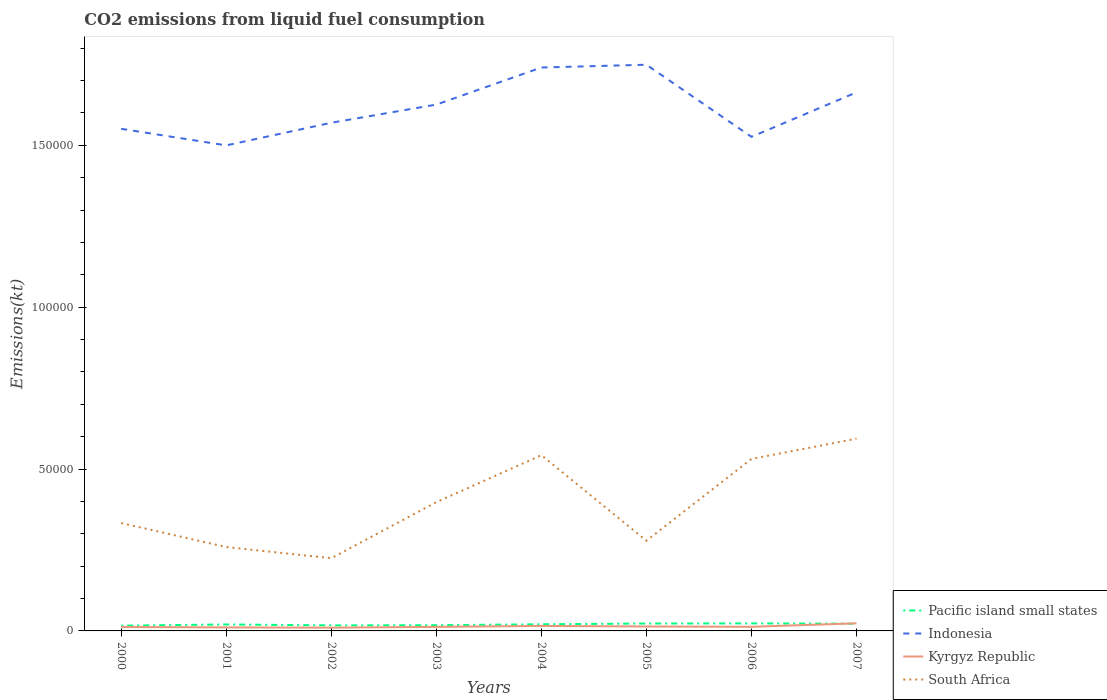Does the line corresponding to South Africa intersect with the line corresponding to Indonesia?
Keep it short and to the point. No. Across all years, what is the maximum amount of CO2 emitted in Indonesia?
Offer a terse response. 1.50e+05. In which year was the amount of CO2 emitted in Indonesia maximum?
Your response must be concise. 2001. What is the total amount of CO2 emitted in South Africa in the graph?
Give a very brief answer. -2.61e+04. What is the difference between the highest and the second highest amount of CO2 emitted in Pacific island small states?
Your answer should be very brief. 697.94. How many years are there in the graph?
Give a very brief answer. 8. Does the graph contain any zero values?
Give a very brief answer. No. How are the legend labels stacked?
Ensure brevity in your answer.  Vertical. What is the title of the graph?
Offer a very short reply. CO2 emissions from liquid fuel consumption. What is the label or title of the X-axis?
Keep it short and to the point. Years. What is the label or title of the Y-axis?
Keep it short and to the point. Emissions(kt). What is the Emissions(kt) of Pacific island small states in 2000?
Provide a succinct answer. 1628.52. What is the Emissions(kt) of Indonesia in 2000?
Offer a terse response. 1.55e+05. What is the Emissions(kt) of Kyrgyz Republic in 2000?
Your answer should be very brief. 1206.44. What is the Emissions(kt) in South Africa in 2000?
Your answer should be very brief. 3.33e+04. What is the Emissions(kt) of Pacific island small states in 2001?
Provide a succinct answer. 1997.8. What is the Emissions(kt) in Indonesia in 2001?
Make the answer very short. 1.50e+05. What is the Emissions(kt) of Kyrgyz Republic in 2001?
Your answer should be compact. 1085.43. What is the Emissions(kt) in South Africa in 2001?
Give a very brief answer. 2.59e+04. What is the Emissions(kt) in Pacific island small states in 2002?
Provide a short and direct response. 1709.77. What is the Emissions(kt) in Indonesia in 2002?
Keep it short and to the point. 1.57e+05. What is the Emissions(kt) of Kyrgyz Republic in 2002?
Your answer should be very brief. 1004.76. What is the Emissions(kt) of South Africa in 2002?
Your answer should be compact. 2.25e+04. What is the Emissions(kt) of Pacific island small states in 2003?
Offer a terse response. 1761.47. What is the Emissions(kt) in Indonesia in 2003?
Keep it short and to the point. 1.63e+05. What is the Emissions(kt) of Kyrgyz Republic in 2003?
Keep it short and to the point. 1246.78. What is the Emissions(kt) of South Africa in 2003?
Give a very brief answer. 3.98e+04. What is the Emissions(kt) of Pacific island small states in 2004?
Provide a succinct answer. 2060.58. What is the Emissions(kt) in Indonesia in 2004?
Provide a short and direct response. 1.74e+05. What is the Emissions(kt) of Kyrgyz Republic in 2004?
Provide a short and direct response. 1543.81. What is the Emissions(kt) of South Africa in 2004?
Offer a very short reply. 5.43e+04. What is the Emissions(kt) in Pacific island small states in 2005?
Give a very brief answer. 2285.84. What is the Emissions(kt) of Indonesia in 2005?
Your answer should be compact. 1.75e+05. What is the Emissions(kt) in Kyrgyz Republic in 2005?
Keep it short and to the point. 1371.46. What is the Emissions(kt) in South Africa in 2005?
Offer a terse response. 2.79e+04. What is the Emissions(kt) in Pacific island small states in 2006?
Give a very brief answer. 2326.46. What is the Emissions(kt) of Indonesia in 2006?
Keep it short and to the point. 1.53e+05. What is the Emissions(kt) of Kyrgyz Republic in 2006?
Keep it short and to the point. 1272.45. What is the Emissions(kt) of South Africa in 2006?
Offer a very short reply. 5.31e+04. What is the Emissions(kt) in Pacific island small states in 2007?
Your response must be concise. 2234.14. What is the Emissions(kt) of Indonesia in 2007?
Offer a terse response. 1.66e+05. What is the Emissions(kt) in Kyrgyz Republic in 2007?
Your answer should be compact. 2346.88. What is the Emissions(kt) in South Africa in 2007?
Make the answer very short. 5.94e+04. Across all years, what is the maximum Emissions(kt) of Pacific island small states?
Ensure brevity in your answer.  2326.46. Across all years, what is the maximum Emissions(kt) of Indonesia?
Keep it short and to the point. 1.75e+05. Across all years, what is the maximum Emissions(kt) of Kyrgyz Republic?
Keep it short and to the point. 2346.88. Across all years, what is the maximum Emissions(kt) of South Africa?
Your response must be concise. 5.94e+04. Across all years, what is the minimum Emissions(kt) in Pacific island small states?
Your answer should be very brief. 1628.52. Across all years, what is the minimum Emissions(kt) of Indonesia?
Your answer should be compact. 1.50e+05. Across all years, what is the minimum Emissions(kt) of Kyrgyz Republic?
Your answer should be compact. 1004.76. Across all years, what is the minimum Emissions(kt) of South Africa?
Provide a succinct answer. 2.25e+04. What is the total Emissions(kt) of Pacific island small states in the graph?
Keep it short and to the point. 1.60e+04. What is the total Emissions(kt) in Indonesia in the graph?
Ensure brevity in your answer.  1.29e+06. What is the total Emissions(kt) of Kyrgyz Republic in the graph?
Give a very brief answer. 1.11e+04. What is the total Emissions(kt) of South Africa in the graph?
Make the answer very short. 3.16e+05. What is the difference between the Emissions(kt) of Pacific island small states in 2000 and that in 2001?
Ensure brevity in your answer.  -369.28. What is the difference between the Emissions(kt) in Indonesia in 2000 and that in 2001?
Ensure brevity in your answer.  5122.8. What is the difference between the Emissions(kt) of Kyrgyz Republic in 2000 and that in 2001?
Give a very brief answer. 121.01. What is the difference between the Emissions(kt) of South Africa in 2000 and that in 2001?
Your response must be concise. 7422.01. What is the difference between the Emissions(kt) of Pacific island small states in 2000 and that in 2002?
Keep it short and to the point. -81.24. What is the difference between the Emissions(kt) of Indonesia in 2000 and that in 2002?
Provide a short and direct response. -1866.5. What is the difference between the Emissions(kt) in Kyrgyz Republic in 2000 and that in 2002?
Give a very brief answer. 201.69. What is the difference between the Emissions(kt) in South Africa in 2000 and that in 2002?
Provide a succinct answer. 1.09e+04. What is the difference between the Emissions(kt) in Pacific island small states in 2000 and that in 2003?
Offer a terse response. -132.94. What is the difference between the Emissions(kt) of Indonesia in 2000 and that in 2003?
Offer a very short reply. -7477.01. What is the difference between the Emissions(kt) in Kyrgyz Republic in 2000 and that in 2003?
Your answer should be very brief. -40.34. What is the difference between the Emissions(kt) in South Africa in 2000 and that in 2003?
Ensure brevity in your answer.  -6446.59. What is the difference between the Emissions(kt) of Pacific island small states in 2000 and that in 2004?
Offer a terse response. -432.06. What is the difference between the Emissions(kt) in Indonesia in 2000 and that in 2004?
Keep it short and to the point. -1.89e+04. What is the difference between the Emissions(kt) in Kyrgyz Republic in 2000 and that in 2004?
Ensure brevity in your answer.  -337.36. What is the difference between the Emissions(kt) in South Africa in 2000 and that in 2004?
Keep it short and to the point. -2.10e+04. What is the difference between the Emissions(kt) of Pacific island small states in 2000 and that in 2005?
Provide a succinct answer. -657.32. What is the difference between the Emissions(kt) in Indonesia in 2000 and that in 2005?
Your response must be concise. -1.98e+04. What is the difference between the Emissions(kt) of Kyrgyz Republic in 2000 and that in 2005?
Your response must be concise. -165.01. What is the difference between the Emissions(kt) in South Africa in 2000 and that in 2005?
Make the answer very short. 5471.16. What is the difference between the Emissions(kt) in Pacific island small states in 2000 and that in 2006?
Your answer should be very brief. -697.94. What is the difference between the Emissions(kt) in Indonesia in 2000 and that in 2006?
Provide a short and direct response. 2478.89. What is the difference between the Emissions(kt) of Kyrgyz Republic in 2000 and that in 2006?
Provide a short and direct response. -66.01. What is the difference between the Emissions(kt) in South Africa in 2000 and that in 2006?
Keep it short and to the point. -1.98e+04. What is the difference between the Emissions(kt) of Pacific island small states in 2000 and that in 2007?
Ensure brevity in your answer.  -605.62. What is the difference between the Emissions(kt) of Indonesia in 2000 and that in 2007?
Offer a terse response. -1.13e+04. What is the difference between the Emissions(kt) in Kyrgyz Republic in 2000 and that in 2007?
Offer a terse response. -1140.44. What is the difference between the Emissions(kt) in South Africa in 2000 and that in 2007?
Keep it short and to the point. -2.61e+04. What is the difference between the Emissions(kt) in Pacific island small states in 2001 and that in 2002?
Provide a short and direct response. 288.04. What is the difference between the Emissions(kt) in Indonesia in 2001 and that in 2002?
Offer a very short reply. -6989.3. What is the difference between the Emissions(kt) in Kyrgyz Republic in 2001 and that in 2002?
Offer a very short reply. 80.67. What is the difference between the Emissions(kt) of South Africa in 2001 and that in 2002?
Make the answer very short. 3439.65. What is the difference between the Emissions(kt) of Pacific island small states in 2001 and that in 2003?
Keep it short and to the point. 236.34. What is the difference between the Emissions(kt) of Indonesia in 2001 and that in 2003?
Provide a succinct answer. -1.26e+04. What is the difference between the Emissions(kt) in Kyrgyz Republic in 2001 and that in 2003?
Your response must be concise. -161.35. What is the difference between the Emissions(kt) in South Africa in 2001 and that in 2003?
Provide a succinct answer. -1.39e+04. What is the difference between the Emissions(kt) in Pacific island small states in 2001 and that in 2004?
Provide a succinct answer. -62.78. What is the difference between the Emissions(kt) in Indonesia in 2001 and that in 2004?
Your answer should be compact. -2.41e+04. What is the difference between the Emissions(kt) in Kyrgyz Republic in 2001 and that in 2004?
Your answer should be compact. -458.38. What is the difference between the Emissions(kt) in South Africa in 2001 and that in 2004?
Ensure brevity in your answer.  -2.84e+04. What is the difference between the Emissions(kt) in Pacific island small states in 2001 and that in 2005?
Keep it short and to the point. -288.04. What is the difference between the Emissions(kt) in Indonesia in 2001 and that in 2005?
Keep it short and to the point. -2.49e+04. What is the difference between the Emissions(kt) of Kyrgyz Republic in 2001 and that in 2005?
Your answer should be very brief. -286.03. What is the difference between the Emissions(kt) in South Africa in 2001 and that in 2005?
Your answer should be very brief. -1950.84. What is the difference between the Emissions(kt) in Pacific island small states in 2001 and that in 2006?
Your answer should be compact. -328.66. What is the difference between the Emissions(kt) in Indonesia in 2001 and that in 2006?
Keep it short and to the point. -2643.91. What is the difference between the Emissions(kt) in Kyrgyz Republic in 2001 and that in 2006?
Offer a very short reply. -187.02. What is the difference between the Emissions(kt) in South Africa in 2001 and that in 2006?
Your answer should be very brief. -2.72e+04. What is the difference between the Emissions(kt) in Pacific island small states in 2001 and that in 2007?
Your answer should be very brief. -236.34. What is the difference between the Emissions(kt) in Indonesia in 2001 and that in 2007?
Give a very brief answer. -1.64e+04. What is the difference between the Emissions(kt) of Kyrgyz Republic in 2001 and that in 2007?
Your response must be concise. -1261.45. What is the difference between the Emissions(kt) of South Africa in 2001 and that in 2007?
Keep it short and to the point. -3.35e+04. What is the difference between the Emissions(kt) in Pacific island small states in 2002 and that in 2003?
Keep it short and to the point. -51.7. What is the difference between the Emissions(kt) in Indonesia in 2002 and that in 2003?
Offer a very short reply. -5610.51. What is the difference between the Emissions(kt) in Kyrgyz Republic in 2002 and that in 2003?
Give a very brief answer. -242.02. What is the difference between the Emissions(kt) in South Africa in 2002 and that in 2003?
Offer a very short reply. -1.73e+04. What is the difference between the Emissions(kt) of Pacific island small states in 2002 and that in 2004?
Your answer should be compact. -350.82. What is the difference between the Emissions(kt) of Indonesia in 2002 and that in 2004?
Your answer should be compact. -1.71e+04. What is the difference between the Emissions(kt) of Kyrgyz Republic in 2002 and that in 2004?
Ensure brevity in your answer.  -539.05. What is the difference between the Emissions(kt) in South Africa in 2002 and that in 2004?
Give a very brief answer. -3.18e+04. What is the difference between the Emissions(kt) of Pacific island small states in 2002 and that in 2005?
Make the answer very short. -576.08. What is the difference between the Emissions(kt) in Indonesia in 2002 and that in 2005?
Offer a terse response. -1.79e+04. What is the difference between the Emissions(kt) of Kyrgyz Republic in 2002 and that in 2005?
Ensure brevity in your answer.  -366.7. What is the difference between the Emissions(kt) of South Africa in 2002 and that in 2005?
Offer a terse response. -5390.49. What is the difference between the Emissions(kt) of Pacific island small states in 2002 and that in 2006?
Keep it short and to the point. -616.7. What is the difference between the Emissions(kt) of Indonesia in 2002 and that in 2006?
Your response must be concise. 4345.4. What is the difference between the Emissions(kt) of Kyrgyz Republic in 2002 and that in 2006?
Make the answer very short. -267.69. What is the difference between the Emissions(kt) of South Africa in 2002 and that in 2006?
Ensure brevity in your answer.  -3.07e+04. What is the difference between the Emissions(kt) of Pacific island small states in 2002 and that in 2007?
Make the answer very short. -524.38. What is the difference between the Emissions(kt) of Indonesia in 2002 and that in 2007?
Provide a succinct answer. -9391.19. What is the difference between the Emissions(kt) of Kyrgyz Republic in 2002 and that in 2007?
Ensure brevity in your answer.  -1342.12. What is the difference between the Emissions(kt) in South Africa in 2002 and that in 2007?
Ensure brevity in your answer.  -3.69e+04. What is the difference between the Emissions(kt) of Pacific island small states in 2003 and that in 2004?
Provide a succinct answer. -299.12. What is the difference between the Emissions(kt) of Indonesia in 2003 and that in 2004?
Provide a short and direct response. -1.15e+04. What is the difference between the Emissions(kt) in Kyrgyz Republic in 2003 and that in 2004?
Your answer should be very brief. -297.03. What is the difference between the Emissions(kt) of South Africa in 2003 and that in 2004?
Offer a very short reply. -1.45e+04. What is the difference between the Emissions(kt) in Pacific island small states in 2003 and that in 2005?
Offer a terse response. -524.38. What is the difference between the Emissions(kt) in Indonesia in 2003 and that in 2005?
Your answer should be very brief. -1.23e+04. What is the difference between the Emissions(kt) of Kyrgyz Republic in 2003 and that in 2005?
Offer a terse response. -124.68. What is the difference between the Emissions(kt) in South Africa in 2003 and that in 2005?
Your answer should be very brief. 1.19e+04. What is the difference between the Emissions(kt) of Pacific island small states in 2003 and that in 2006?
Give a very brief answer. -565. What is the difference between the Emissions(kt) of Indonesia in 2003 and that in 2006?
Give a very brief answer. 9955.91. What is the difference between the Emissions(kt) of Kyrgyz Republic in 2003 and that in 2006?
Offer a very short reply. -25.67. What is the difference between the Emissions(kt) of South Africa in 2003 and that in 2006?
Offer a terse response. -1.34e+04. What is the difference between the Emissions(kt) in Pacific island small states in 2003 and that in 2007?
Your response must be concise. -472.68. What is the difference between the Emissions(kt) of Indonesia in 2003 and that in 2007?
Your response must be concise. -3780.68. What is the difference between the Emissions(kt) of Kyrgyz Republic in 2003 and that in 2007?
Provide a short and direct response. -1100.1. What is the difference between the Emissions(kt) in South Africa in 2003 and that in 2007?
Make the answer very short. -1.96e+04. What is the difference between the Emissions(kt) of Pacific island small states in 2004 and that in 2005?
Provide a short and direct response. -225.26. What is the difference between the Emissions(kt) in Indonesia in 2004 and that in 2005?
Your response must be concise. -861.75. What is the difference between the Emissions(kt) of Kyrgyz Republic in 2004 and that in 2005?
Offer a terse response. 172.35. What is the difference between the Emissions(kt) in South Africa in 2004 and that in 2005?
Ensure brevity in your answer.  2.64e+04. What is the difference between the Emissions(kt) in Pacific island small states in 2004 and that in 2006?
Provide a short and direct response. -265.88. What is the difference between the Emissions(kt) of Indonesia in 2004 and that in 2006?
Offer a terse response. 2.14e+04. What is the difference between the Emissions(kt) in Kyrgyz Republic in 2004 and that in 2006?
Make the answer very short. 271.36. What is the difference between the Emissions(kt) of South Africa in 2004 and that in 2006?
Your answer should be very brief. 1151.44. What is the difference between the Emissions(kt) of Pacific island small states in 2004 and that in 2007?
Ensure brevity in your answer.  -173.56. What is the difference between the Emissions(kt) in Indonesia in 2004 and that in 2007?
Ensure brevity in your answer.  7675.03. What is the difference between the Emissions(kt) in Kyrgyz Republic in 2004 and that in 2007?
Offer a terse response. -803.07. What is the difference between the Emissions(kt) in South Africa in 2004 and that in 2007?
Offer a very short reply. -5104.46. What is the difference between the Emissions(kt) in Pacific island small states in 2005 and that in 2006?
Provide a succinct answer. -40.62. What is the difference between the Emissions(kt) in Indonesia in 2005 and that in 2006?
Your response must be concise. 2.23e+04. What is the difference between the Emissions(kt) in Kyrgyz Republic in 2005 and that in 2006?
Offer a terse response. 99.01. What is the difference between the Emissions(kt) of South Africa in 2005 and that in 2006?
Ensure brevity in your answer.  -2.53e+04. What is the difference between the Emissions(kt) of Pacific island small states in 2005 and that in 2007?
Provide a succinct answer. 51.7. What is the difference between the Emissions(kt) in Indonesia in 2005 and that in 2007?
Your response must be concise. 8536.78. What is the difference between the Emissions(kt) of Kyrgyz Republic in 2005 and that in 2007?
Ensure brevity in your answer.  -975.42. What is the difference between the Emissions(kt) in South Africa in 2005 and that in 2007?
Give a very brief answer. -3.15e+04. What is the difference between the Emissions(kt) in Pacific island small states in 2006 and that in 2007?
Keep it short and to the point. 92.32. What is the difference between the Emissions(kt) in Indonesia in 2006 and that in 2007?
Your answer should be very brief. -1.37e+04. What is the difference between the Emissions(kt) in Kyrgyz Republic in 2006 and that in 2007?
Ensure brevity in your answer.  -1074.43. What is the difference between the Emissions(kt) of South Africa in 2006 and that in 2007?
Your answer should be compact. -6255.9. What is the difference between the Emissions(kt) of Pacific island small states in 2000 and the Emissions(kt) of Indonesia in 2001?
Your answer should be compact. -1.48e+05. What is the difference between the Emissions(kt) in Pacific island small states in 2000 and the Emissions(kt) in Kyrgyz Republic in 2001?
Provide a short and direct response. 543.09. What is the difference between the Emissions(kt) in Pacific island small states in 2000 and the Emissions(kt) in South Africa in 2001?
Keep it short and to the point. -2.43e+04. What is the difference between the Emissions(kt) in Indonesia in 2000 and the Emissions(kt) in Kyrgyz Republic in 2001?
Provide a short and direct response. 1.54e+05. What is the difference between the Emissions(kt) of Indonesia in 2000 and the Emissions(kt) of South Africa in 2001?
Give a very brief answer. 1.29e+05. What is the difference between the Emissions(kt) in Kyrgyz Republic in 2000 and the Emissions(kt) in South Africa in 2001?
Your response must be concise. -2.47e+04. What is the difference between the Emissions(kt) in Pacific island small states in 2000 and the Emissions(kt) in Indonesia in 2002?
Your answer should be very brief. -1.55e+05. What is the difference between the Emissions(kt) of Pacific island small states in 2000 and the Emissions(kt) of Kyrgyz Republic in 2002?
Offer a very short reply. 623.77. What is the difference between the Emissions(kt) of Pacific island small states in 2000 and the Emissions(kt) of South Africa in 2002?
Offer a very short reply. -2.08e+04. What is the difference between the Emissions(kt) of Indonesia in 2000 and the Emissions(kt) of Kyrgyz Republic in 2002?
Make the answer very short. 1.54e+05. What is the difference between the Emissions(kt) in Indonesia in 2000 and the Emissions(kt) in South Africa in 2002?
Give a very brief answer. 1.33e+05. What is the difference between the Emissions(kt) in Kyrgyz Republic in 2000 and the Emissions(kt) in South Africa in 2002?
Provide a short and direct response. -2.13e+04. What is the difference between the Emissions(kt) in Pacific island small states in 2000 and the Emissions(kt) in Indonesia in 2003?
Your response must be concise. -1.61e+05. What is the difference between the Emissions(kt) in Pacific island small states in 2000 and the Emissions(kt) in Kyrgyz Republic in 2003?
Your answer should be compact. 381.74. What is the difference between the Emissions(kt) of Pacific island small states in 2000 and the Emissions(kt) of South Africa in 2003?
Provide a succinct answer. -3.81e+04. What is the difference between the Emissions(kt) in Indonesia in 2000 and the Emissions(kt) in Kyrgyz Republic in 2003?
Your response must be concise. 1.54e+05. What is the difference between the Emissions(kt) of Indonesia in 2000 and the Emissions(kt) of South Africa in 2003?
Ensure brevity in your answer.  1.15e+05. What is the difference between the Emissions(kt) of Kyrgyz Republic in 2000 and the Emissions(kt) of South Africa in 2003?
Offer a very short reply. -3.86e+04. What is the difference between the Emissions(kt) of Pacific island small states in 2000 and the Emissions(kt) of Indonesia in 2004?
Provide a short and direct response. -1.72e+05. What is the difference between the Emissions(kt) of Pacific island small states in 2000 and the Emissions(kt) of Kyrgyz Republic in 2004?
Provide a short and direct response. 84.72. What is the difference between the Emissions(kt) of Pacific island small states in 2000 and the Emissions(kt) of South Africa in 2004?
Provide a short and direct response. -5.27e+04. What is the difference between the Emissions(kt) in Indonesia in 2000 and the Emissions(kt) in Kyrgyz Republic in 2004?
Your response must be concise. 1.54e+05. What is the difference between the Emissions(kt) of Indonesia in 2000 and the Emissions(kt) of South Africa in 2004?
Provide a short and direct response. 1.01e+05. What is the difference between the Emissions(kt) of Kyrgyz Republic in 2000 and the Emissions(kt) of South Africa in 2004?
Ensure brevity in your answer.  -5.31e+04. What is the difference between the Emissions(kt) in Pacific island small states in 2000 and the Emissions(kt) in Indonesia in 2005?
Offer a very short reply. -1.73e+05. What is the difference between the Emissions(kt) of Pacific island small states in 2000 and the Emissions(kt) of Kyrgyz Republic in 2005?
Ensure brevity in your answer.  257.07. What is the difference between the Emissions(kt) of Pacific island small states in 2000 and the Emissions(kt) of South Africa in 2005?
Offer a terse response. -2.62e+04. What is the difference between the Emissions(kt) of Indonesia in 2000 and the Emissions(kt) of Kyrgyz Republic in 2005?
Your answer should be compact. 1.54e+05. What is the difference between the Emissions(kt) in Indonesia in 2000 and the Emissions(kt) in South Africa in 2005?
Offer a very short reply. 1.27e+05. What is the difference between the Emissions(kt) in Kyrgyz Republic in 2000 and the Emissions(kt) in South Africa in 2005?
Keep it short and to the point. -2.67e+04. What is the difference between the Emissions(kt) in Pacific island small states in 2000 and the Emissions(kt) in Indonesia in 2006?
Keep it short and to the point. -1.51e+05. What is the difference between the Emissions(kt) in Pacific island small states in 2000 and the Emissions(kt) in Kyrgyz Republic in 2006?
Your answer should be very brief. 356.08. What is the difference between the Emissions(kt) in Pacific island small states in 2000 and the Emissions(kt) in South Africa in 2006?
Your answer should be very brief. -5.15e+04. What is the difference between the Emissions(kt) in Indonesia in 2000 and the Emissions(kt) in Kyrgyz Republic in 2006?
Keep it short and to the point. 1.54e+05. What is the difference between the Emissions(kt) of Indonesia in 2000 and the Emissions(kt) of South Africa in 2006?
Provide a succinct answer. 1.02e+05. What is the difference between the Emissions(kt) of Kyrgyz Republic in 2000 and the Emissions(kt) of South Africa in 2006?
Offer a very short reply. -5.19e+04. What is the difference between the Emissions(kt) in Pacific island small states in 2000 and the Emissions(kt) in Indonesia in 2007?
Offer a very short reply. -1.65e+05. What is the difference between the Emissions(kt) of Pacific island small states in 2000 and the Emissions(kt) of Kyrgyz Republic in 2007?
Provide a short and direct response. -718.36. What is the difference between the Emissions(kt) in Pacific island small states in 2000 and the Emissions(kt) in South Africa in 2007?
Your response must be concise. -5.78e+04. What is the difference between the Emissions(kt) in Indonesia in 2000 and the Emissions(kt) in Kyrgyz Republic in 2007?
Make the answer very short. 1.53e+05. What is the difference between the Emissions(kt) of Indonesia in 2000 and the Emissions(kt) of South Africa in 2007?
Provide a succinct answer. 9.57e+04. What is the difference between the Emissions(kt) in Kyrgyz Republic in 2000 and the Emissions(kt) in South Africa in 2007?
Provide a succinct answer. -5.82e+04. What is the difference between the Emissions(kt) in Pacific island small states in 2001 and the Emissions(kt) in Indonesia in 2002?
Offer a terse response. -1.55e+05. What is the difference between the Emissions(kt) in Pacific island small states in 2001 and the Emissions(kt) in Kyrgyz Republic in 2002?
Provide a succinct answer. 993.05. What is the difference between the Emissions(kt) of Pacific island small states in 2001 and the Emissions(kt) of South Africa in 2002?
Provide a short and direct response. -2.05e+04. What is the difference between the Emissions(kt) in Indonesia in 2001 and the Emissions(kt) in Kyrgyz Republic in 2002?
Offer a very short reply. 1.49e+05. What is the difference between the Emissions(kt) of Indonesia in 2001 and the Emissions(kt) of South Africa in 2002?
Offer a terse response. 1.28e+05. What is the difference between the Emissions(kt) of Kyrgyz Republic in 2001 and the Emissions(kt) of South Africa in 2002?
Offer a very short reply. -2.14e+04. What is the difference between the Emissions(kt) of Pacific island small states in 2001 and the Emissions(kt) of Indonesia in 2003?
Your answer should be very brief. -1.61e+05. What is the difference between the Emissions(kt) in Pacific island small states in 2001 and the Emissions(kt) in Kyrgyz Republic in 2003?
Provide a short and direct response. 751.02. What is the difference between the Emissions(kt) of Pacific island small states in 2001 and the Emissions(kt) of South Africa in 2003?
Your answer should be very brief. -3.78e+04. What is the difference between the Emissions(kt) of Indonesia in 2001 and the Emissions(kt) of Kyrgyz Republic in 2003?
Keep it short and to the point. 1.49e+05. What is the difference between the Emissions(kt) of Indonesia in 2001 and the Emissions(kt) of South Africa in 2003?
Ensure brevity in your answer.  1.10e+05. What is the difference between the Emissions(kt) of Kyrgyz Republic in 2001 and the Emissions(kt) of South Africa in 2003?
Make the answer very short. -3.87e+04. What is the difference between the Emissions(kt) in Pacific island small states in 2001 and the Emissions(kt) in Indonesia in 2004?
Offer a very short reply. -1.72e+05. What is the difference between the Emissions(kt) of Pacific island small states in 2001 and the Emissions(kt) of Kyrgyz Republic in 2004?
Provide a succinct answer. 454. What is the difference between the Emissions(kt) of Pacific island small states in 2001 and the Emissions(kt) of South Africa in 2004?
Offer a very short reply. -5.23e+04. What is the difference between the Emissions(kt) in Indonesia in 2001 and the Emissions(kt) in Kyrgyz Republic in 2004?
Your response must be concise. 1.48e+05. What is the difference between the Emissions(kt) in Indonesia in 2001 and the Emissions(kt) in South Africa in 2004?
Offer a very short reply. 9.57e+04. What is the difference between the Emissions(kt) of Kyrgyz Republic in 2001 and the Emissions(kt) of South Africa in 2004?
Your response must be concise. -5.32e+04. What is the difference between the Emissions(kt) of Pacific island small states in 2001 and the Emissions(kt) of Indonesia in 2005?
Your response must be concise. -1.73e+05. What is the difference between the Emissions(kt) of Pacific island small states in 2001 and the Emissions(kt) of Kyrgyz Republic in 2005?
Provide a short and direct response. 626.35. What is the difference between the Emissions(kt) in Pacific island small states in 2001 and the Emissions(kt) in South Africa in 2005?
Offer a very short reply. -2.59e+04. What is the difference between the Emissions(kt) of Indonesia in 2001 and the Emissions(kt) of Kyrgyz Republic in 2005?
Keep it short and to the point. 1.49e+05. What is the difference between the Emissions(kt) in Indonesia in 2001 and the Emissions(kt) in South Africa in 2005?
Offer a very short reply. 1.22e+05. What is the difference between the Emissions(kt) in Kyrgyz Republic in 2001 and the Emissions(kt) in South Africa in 2005?
Your answer should be compact. -2.68e+04. What is the difference between the Emissions(kt) in Pacific island small states in 2001 and the Emissions(kt) in Indonesia in 2006?
Provide a short and direct response. -1.51e+05. What is the difference between the Emissions(kt) of Pacific island small states in 2001 and the Emissions(kt) of Kyrgyz Republic in 2006?
Provide a succinct answer. 725.36. What is the difference between the Emissions(kt) in Pacific island small states in 2001 and the Emissions(kt) in South Africa in 2006?
Provide a succinct answer. -5.11e+04. What is the difference between the Emissions(kt) in Indonesia in 2001 and the Emissions(kt) in Kyrgyz Republic in 2006?
Provide a succinct answer. 1.49e+05. What is the difference between the Emissions(kt) in Indonesia in 2001 and the Emissions(kt) in South Africa in 2006?
Provide a succinct answer. 9.68e+04. What is the difference between the Emissions(kt) of Kyrgyz Republic in 2001 and the Emissions(kt) of South Africa in 2006?
Offer a terse response. -5.20e+04. What is the difference between the Emissions(kt) in Pacific island small states in 2001 and the Emissions(kt) in Indonesia in 2007?
Your answer should be very brief. -1.64e+05. What is the difference between the Emissions(kt) of Pacific island small states in 2001 and the Emissions(kt) of Kyrgyz Republic in 2007?
Provide a succinct answer. -349.08. What is the difference between the Emissions(kt) of Pacific island small states in 2001 and the Emissions(kt) of South Africa in 2007?
Your answer should be compact. -5.74e+04. What is the difference between the Emissions(kt) of Indonesia in 2001 and the Emissions(kt) of Kyrgyz Republic in 2007?
Offer a very short reply. 1.48e+05. What is the difference between the Emissions(kt) in Indonesia in 2001 and the Emissions(kt) in South Africa in 2007?
Your response must be concise. 9.06e+04. What is the difference between the Emissions(kt) of Kyrgyz Republic in 2001 and the Emissions(kt) of South Africa in 2007?
Your response must be concise. -5.83e+04. What is the difference between the Emissions(kt) in Pacific island small states in 2002 and the Emissions(kt) in Indonesia in 2003?
Provide a short and direct response. -1.61e+05. What is the difference between the Emissions(kt) in Pacific island small states in 2002 and the Emissions(kt) in Kyrgyz Republic in 2003?
Offer a terse response. 462.99. What is the difference between the Emissions(kt) of Pacific island small states in 2002 and the Emissions(kt) of South Africa in 2003?
Ensure brevity in your answer.  -3.81e+04. What is the difference between the Emissions(kt) in Indonesia in 2002 and the Emissions(kt) in Kyrgyz Republic in 2003?
Your answer should be very brief. 1.56e+05. What is the difference between the Emissions(kt) of Indonesia in 2002 and the Emissions(kt) of South Africa in 2003?
Make the answer very short. 1.17e+05. What is the difference between the Emissions(kt) in Kyrgyz Republic in 2002 and the Emissions(kt) in South Africa in 2003?
Make the answer very short. -3.88e+04. What is the difference between the Emissions(kt) in Pacific island small states in 2002 and the Emissions(kt) in Indonesia in 2004?
Give a very brief answer. -1.72e+05. What is the difference between the Emissions(kt) in Pacific island small states in 2002 and the Emissions(kt) in Kyrgyz Republic in 2004?
Give a very brief answer. 165.96. What is the difference between the Emissions(kt) of Pacific island small states in 2002 and the Emissions(kt) of South Africa in 2004?
Give a very brief answer. -5.26e+04. What is the difference between the Emissions(kt) of Indonesia in 2002 and the Emissions(kt) of Kyrgyz Republic in 2004?
Keep it short and to the point. 1.55e+05. What is the difference between the Emissions(kt) of Indonesia in 2002 and the Emissions(kt) of South Africa in 2004?
Your response must be concise. 1.03e+05. What is the difference between the Emissions(kt) of Kyrgyz Republic in 2002 and the Emissions(kt) of South Africa in 2004?
Ensure brevity in your answer.  -5.33e+04. What is the difference between the Emissions(kt) of Pacific island small states in 2002 and the Emissions(kt) of Indonesia in 2005?
Provide a short and direct response. -1.73e+05. What is the difference between the Emissions(kt) in Pacific island small states in 2002 and the Emissions(kt) in Kyrgyz Republic in 2005?
Offer a terse response. 338.31. What is the difference between the Emissions(kt) of Pacific island small states in 2002 and the Emissions(kt) of South Africa in 2005?
Provide a succinct answer. -2.61e+04. What is the difference between the Emissions(kt) of Indonesia in 2002 and the Emissions(kt) of Kyrgyz Republic in 2005?
Provide a short and direct response. 1.56e+05. What is the difference between the Emissions(kt) of Indonesia in 2002 and the Emissions(kt) of South Africa in 2005?
Ensure brevity in your answer.  1.29e+05. What is the difference between the Emissions(kt) of Kyrgyz Republic in 2002 and the Emissions(kt) of South Africa in 2005?
Your answer should be very brief. -2.69e+04. What is the difference between the Emissions(kt) of Pacific island small states in 2002 and the Emissions(kt) of Indonesia in 2006?
Your answer should be very brief. -1.51e+05. What is the difference between the Emissions(kt) of Pacific island small states in 2002 and the Emissions(kt) of Kyrgyz Republic in 2006?
Your answer should be very brief. 437.32. What is the difference between the Emissions(kt) of Pacific island small states in 2002 and the Emissions(kt) of South Africa in 2006?
Offer a very short reply. -5.14e+04. What is the difference between the Emissions(kt) in Indonesia in 2002 and the Emissions(kt) in Kyrgyz Republic in 2006?
Provide a succinct answer. 1.56e+05. What is the difference between the Emissions(kt) of Indonesia in 2002 and the Emissions(kt) of South Africa in 2006?
Give a very brief answer. 1.04e+05. What is the difference between the Emissions(kt) in Kyrgyz Republic in 2002 and the Emissions(kt) in South Africa in 2006?
Your response must be concise. -5.21e+04. What is the difference between the Emissions(kt) in Pacific island small states in 2002 and the Emissions(kt) in Indonesia in 2007?
Provide a succinct answer. -1.65e+05. What is the difference between the Emissions(kt) of Pacific island small states in 2002 and the Emissions(kt) of Kyrgyz Republic in 2007?
Your response must be concise. -637.11. What is the difference between the Emissions(kt) in Pacific island small states in 2002 and the Emissions(kt) in South Africa in 2007?
Make the answer very short. -5.77e+04. What is the difference between the Emissions(kt) of Indonesia in 2002 and the Emissions(kt) of Kyrgyz Republic in 2007?
Offer a very short reply. 1.55e+05. What is the difference between the Emissions(kt) of Indonesia in 2002 and the Emissions(kt) of South Africa in 2007?
Your answer should be compact. 9.76e+04. What is the difference between the Emissions(kt) in Kyrgyz Republic in 2002 and the Emissions(kt) in South Africa in 2007?
Your response must be concise. -5.84e+04. What is the difference between the Emissions(kt) in Pacific island small states in 2003 and the Emissions(kt) in Indonesia in 2004?
Offer a very short reply. -1.72e+05. What is the difference between the Emissions(kt) of Pacific island small states in 2003 and the Emissions(kt) of Kyrgyz Republic in 2004?
Give a very brief answer. 217.66. What is the difference between the Emissions(kt) in Pacific island small states in 2003 and the Emissions(kt) in South Africa in 2004?
Give a very brief answer. -5.25e+04. What is the difference between the Emissions(kt) in Indonesia in 2003 and the Emissions(kt) in Kyrgyz Republic in 2004?
Your answer should be compact. 1.61e+05. What is the difference between the Emissions(kt) in Indonesia in 2003 and the Emissions(kt) in South Africa in 2004?
Provide a short and direct response. 1.08e+05. What is the difference between the Emissions(kt) in Kyrgyz Republic in 2003 and the Emissions(kt) in South Africa in 2004?
Your answer should be very brief. -5.30e+04. What is the difference between the Emissions(kt) of Pacific island small states in 2003 and the Emissions(kt) of Indonesia in 2005?
Keep it short and to the point. -1.73e+05. What is the difference between the Emissions(kt) in Pacific island small states in 2003 and the Emissions(kt) in Kyrgyz Republic in 2005?
Keep it short and to the point. 390.01. What is the difference between the Emissions(kt) of Pacific island small states in 2003 and the Emissions(kt) of South Africa in 2005?
Your answer should be compact. -2.61e+04. What is the difference between the Emissions(kt) of Indonesia in 2003 and the Emissions(kt) of Kyrgyz Republic in 2005?
Keep it short and to the point. 1.61e+05. What is the difference between the Emissions(kt) of Indonesia in 2003 and the Emissions(kt) of South Africa in 2005?
Your response must be concise. 1.35e+05. What is the difference between the Emissions(kt) in Kyrgyz Republic in 2003 and the Emissions(kt) in South Africa in 2005?
Keep it short and to the point. -2.66e+04. What is the difference between the Emissions(kt) of Pacific island small states in 2003 and the Emissions(kt) of Indonesia in 2006?
Provide a succinct answer. -1.51e+05. What is the difference between the Emissions(kt) in Pacific island small states in 2003 and the Emissions(kt) in Kyrgyz Republic in 2006?
Provide a short and direct response. 489.02. What is the difference between the Emissions(kt) of Pacific island small states in 2003 and the Emissions(kt) of South Africa in 2006?
Give a very brief answer. -5.14e+04. What is the difference between the Emissions(kt) of Indonesia in 2003 and the Emissions(kt) of Kyrgyz Republic in 2006?
Your response must be concise. 1.61e+05. What is the difference between the Emissions(kt) of Indonesia in 2003 and the Emissions(kt) of South Africa in 2006?
Your answer should be very brief. 1.09e+05. What is the difference between the Emissions(kt) in Kyrgyz Republic in 2003 and the Emissions(kt) in South Africa in 2006?
Keep it short and to the point. -5.19e+04. What is the difference between the Emissions(kt) in Pacific island small states in 2003 and the Emissions(kt) in Indonesia in 2007?
Keep it short and to the point. -1.65e+05. What is the difference between the Emissions(kt) in Pacific island small states in 2003 and the Emissions(kt) in Kyrgyz Republic in 2007?
Offer a terse response. -585.41. What is the difference between the Emissions(kt) of Pacific island small states in 2003 and the Emissions(kt) of South Africa in 2007?
Make the answer very short. -5.76e+04. What is the difference between the Emissions(kt) in Indonesia in 2003 and the Emissions(kt) in Kyrgyz Republic in 2007?
Give a very brief answer. 1.60e+05. What is the difference between the Emissions(kt) in Indonesia in 2003 and the Emissions(kt) in South Africa in 2007?
Give a very brief answer. 1.03e+05. What is the difference between the Emissions(kt) of Kyrgyz Republic in 2003 and the Emissions(kt) of South Africa in 2007?
Keep it short and to the point. -5.81e+04. What is the difference between the Emissions(kt) in Pacific island small states in 2004 and the Emissions(kt) in Indonesia in 2005?
Ensure brevity in your answer.  -1.73e+05. What is the difference between the Emissions(kt) of Pacific island small states in 2004 and the Emissions(kt) of Kyrgyz Republic in 2005?
Your response must be concise. 689.12. What is the difference between the Emissions(kt) of Pacific island small states in 2004 and the Emissions(kt) of South Africa in 2005?
Offer a very short reply. -2.58e+04. What is the difference between the Emissions(kt) of Indonesia in 2004 and the Emissions(kt) of Kyrgyz Republic in 2005?
Make the answer very short. 1.73e+05. What is the difference between the Emissions(kt) in Indonesia in 2004 and the Emissions(kt) in South Africa in 2005?
Your answer should be compact. 1.46e+05. What is the difference between the Emissions(kt) in Kyrgyz Republic in 2004 and the Emissions(kt) in South Africa in 2005?
Give a very brief answer. -2.63e+04. What is the difference between the Emissions(kt) in Pacific island small states in 2004 and the Emissions(kt) in Indonesia in 2006?
Offer a very short reply. -1.51e+05. What is the difference between the Emissions(kt) of Pacific island small states in 2004 and the Emissions(kt) of Kyrgyz Republic in 2006?
Your response must be concise. 788.13. What is the difference between the Emissions(kt) in Pacific island small states in 2004 and the Emissions(kt) in South Africa in 2006?
Give a very brief answer. -5.11e+04. What is the difference between the Emissions(kt) in Indonesia in 2004 and the Emissions(kt) in Kyrgyz Republic in 2006?
Make the answer very short. 1.73e+05. What is the difference between the Emissions(kt) of Indonesia in 2004 and the Emissions(kt) of South Africa in 2006?
Your answer should be compact. 1.21e+05. What is the difference between the Emissions(kt) of Kyrgyz Republic in 2004 and the Emissions(kt) of South Africa in 2006?
Keep it short and to the point. -5.16e+04. What is the difference between the Emissions(kt) of Pacific island small states in 2004 and the Emissions(kt) of Indonesia in 2007?
Offer a very short reply. -1.64e+05. What is the difference between the Emissions(kt) in Pacific island small states in 2004 and the Emissions(kt) in Kyrgyz Republic in 2007?
Provide a succinct answer. -286.3. What is the difference between the Emissions(kt) in Pacific island small states in 2004 and the Emissions(kt) in South Africa in 2007?
Provide a succinct answer. -5.73e+04. What is the difference between the Emissions(kt) of Indonesia in 2004 and the Emissions(kt) of Kyrgyz Republic in 2007?
Your answer should be compact. 1.72e+05. What is the difference between the Emissions(kt) of Indonesia in 2004 and the Emissions(kt) of South Africa in 2007?
Offer a terse response. 1.15e+05. What is the difference between the Emissions(kt) in Kyrgyz Republic in 2004 and the Emissions(kt) in South Africa in 2007?
Your answer should be compact. -5.78e+04. What is the difference between the Emissions(kt) in Pacific island small states in 2005 and the Emissions(kt) in Indonesia in 2006?
Provide a short and direct response. -1.50e+05. What is the difference between the Emissions(kt) of Pacific island small states in 2005 and the Emissions(kt) of Kyrgyz Republic in 2006?
Make the answer very short. 1013.39. What is the difference between the Emissions(kt) in Pacific island small states in 2005 and the Emissions(kt) in South Africa in 2006?
Offer a very short reply. -5.08e+04. What is the difference between the Emissions(kt) in Indonesia in 2005 and the Emissions(kt) in Kyrgyz Republic in 2006?
Provide a succinct answer. 1.74e+05. What is the difference between the Emissions(kt) in Indonesia in 2005 and the Emissions(kt) in South Africa in 2006?
Make the answer very short. 1.22e+05. What is the difference between the Emissions(kt) of Kyrgyz Republic in 2005 and the Emissions(kt) of South Africa in 2006?
Offer a very short reply. -5.18e+04. What is the difference between the Emissions(kt) in Pacific island small states in 2005 and the Emissions(kt) in Indonesia in 2007?
Keep it short and to the point. -1.64e+05. What is the difference between the Emissions(kt) of Pacific island small states in 2005 and the Emissions(kt) of Kyrgyz Republic in 2007?
Ensure brevity in your answer.  -61.04. What is the difference between the Emissions(kt) of Pacific island small states in 2005 and the Emissions(kt) of South Africa in 2007?
Provide a short and direct response. -5.71e+04. What is the difference between the Emissions(kt) of Indonesia in 2005 and the Emissions(kt) of Kyrgyz Republic in 2007?
Provide a succinct answer. 1.73e+05. What is the difference between the Emissions(kt) of Indonesia in 2005 and the Emissions(kt) of South Africa in 2007?
Provide a succinct answer. 1.16e+05. What is the difference between the Emissions(kt) of Kyrgyz Republic in 2005 and the Emissions(kt) of South Africa in 2007?
Provide a short and direct response. -5.80e+04. What is the difference between the Emissions(kt) of Pacific island small states in 2006 and the Emissions(kt) of Indonesia in 2007?
Keep it short and to the point. -1.64e+05. What is the difference between the Emissions(kt) of Pacific island small states in 2006 and the Emissions(kt) of Kyrgyz Republic in 2007?
Offer a very short reply. -20.42. What is the difference between the Emissions(kt) of Pacific island small states in 2006 and the Emissions(kt) of South Africa in 2007?
Your answer should be very brief. -5.71e+04. What is the difference between the Emissions(kt) in Indonesia in 2006 and the Emissions(kt) in Kyrgyz Republic in 2007?
Your answer should be very brief. 1.50e+05. What is the difference between the Emissions(kt) in Indonesia in 2006 and the Emissions(kt) in South Africa in 2007?
Make the answer very short. 9.32e+04. What is the difference between the Emissions(kt) of Kyrgyz Republic in 2006 and the Emissions(kt) of South Africa in 2007?
Provide a succinct answer. -5.81e+04. What is the average Emissions(kt) of Pacific island small states per year?
Ensure brevity in your answer.  2000.57. What is the average Emissions(kt) in Indonesia per year?
Offer a very short reply. 1.62e+05. What is the average Emissions(kt) of Kyrgyz Republic per year?
Make the answer very short. 1384.75. What is the average Emissions(kt) of South Africa per year?
Your answer should be very brief. 3.95e+04. In the year 2000, what is the difference between the Emissions(kt) of Pacific island small states and Emissions(kt) of Indonesia?
Make the answer very short. -1.53e+05. In the year 2000, what is the difference between the Emissions(kt) in Pacific island small states and Emissions(kt) in Kyrgyz Republic?
Offer a very short reply. 422.08. In the year 2000, what is the difference between the Emissions(kt) of Pacific island small states and Emissions(kt) of South Africa?
Provide a succinct answer. -3.17e+04. In the year 2000, what is the difference between the Emissions(kt) of Indonesia and Emissions(kt) of Kyrgyz Republic?
Provide a short and direct response. 1.54e+05. In the year 2000, what is the difference between the Emissions(kt) of Indonesia and Emissions(kt) of South Africa?
Your answer should be compact. 1.22e+05. In the year 2000, what is the difference between the Emissions(kt) in Kyrgyz Republic and Emissions(kt) in South Africa?
Make the answer very short. -3.21e+04. In the year 2001, what is the difference between the Emissions(kt) in Pacific island small states and Emissions(kt) in Indonesia?
Your response must be concise. -1.48e+05. In the year 2001, what is the difference between the Emissions(kt) of Pacific island small states and Emissions(kt) of Kyrgyz Republic?
Keep it short and to the point. 912.37. In the year 2001, what is the difference between the Emissions(kt) in Pacific island small states and Emissions(kt) in South Africa?
Make the answer very short. -2.39e+04. In the year 2001, what is the difference between the Emissions(kt) of Indonesia and Emissions(kt) of Kyrgyz Republic?
Your answer should be very brief. 1.49e+05. In the year 2001, what is the difference between the Emissions(kt) of Indonesia and Emissions(kt) of South Africa?
Offer a terse response. 1.24e+05. In the year 2001, what is the difference between the Emissions(kt) of Kyrgyz Republic and Emissions(kt) of South Africa?
Provide a short and direct response. -2.48e+04. In the year 2002, what is the difference between the Emissions(kt) of Pacific island small states and Emissions(kt) of Indonesia?
Your answer should be very brief. -1.55e+05. In the year 2002, what is the difference between the Emissions(kt) of Pacific island small states and Emissions(kt) of Kyrgyz Republic?
Give a very brief answer. 705.01. In the year 2002, what is the difference between the Emissions(kt) in Pacific island small states and Emissions(kt) in South Africa?
Give a very brief answer. -2.08e+04. In the year 2002, what is the difference between the Emissions(kt) of Indonesia and Emissions(kt) of Kyrgyz Republic?
Your answer should be compact. 1.56e+05. In the year 2002, what is the difference between the Emissions(kt) of Indonesia and Emissions(kt) of South Africa?
Provide a succinct answer. 1.35e+05. In the year 2002, what is the difference between the Emissions(kt) of Kyrgyz Republic and Emissions(kt) of South Africa?
Ensure brevity in your answer.  -2.15e+04. In the year 2003, what is the difference between the Emissions(kt) of Pacific island small states and Emissions(kt) of Indonesia?
Offer a very short reply. -1.61e+05. In the year 2003, what is the difference between the Emissions(kt) of Pacific island small states and Emissions(kt) of Kyrgyz Republic?
Provide a succinct answer. 514.69. In the year 2003, what is the difference between the Emissions(kt) in Pacific island small states and Emissions(kt) in South Africa?
Provide a succinct answer. -3.80e+04. In the year 2003, what is the difference between the Emissions(kt) in Indonesia and Emissions(kt) in Kyrgyz Republic?
Offer a very short reply. 1.61e+05. In the year 2003, what is the difference between the Emissions(kt) in Indonesia and Emissions(kt) in South Africa?
Ensure brevity in your answer.  1.23e+05. In the year 2003, what is the difference between the Emissions(kt) in Kyrgyz Republic and Emissions(kt) in South Africa?
Keep it short and to the point. -3.85e+04. In the year 2004, what is the difference between the Emissions(kt) in Pacific island small states and Emissions(kt) in Indonesia?
Offer a very short reply. -1.72e+05. In the year 2004, what is the difference between the Emissions(kt) of Pacific island small states and Emissions(kt) of Kyrgyz Republic?
Give a very brief answer. 516.78. In the year 2004, what is the difference between the Emissions(kt) in Pacific island small states and Emissions(kt) in South Africa?
Keep it short and to the point. -5.22e+04. In the year 2004, what is the difference between the Emissions(kt) of Indonesia and Emissions(kt) of Kyrgyz Republic?
Your answer should be compact. 1.72e+05. In the year 2004, what is the difference between the Emissions(kt) in Indonesia and Emissions(kt) in South Africa?
Offer a terse response. 1.20e+05. In the year 2004, what is the difference between the Emissions(kt) of Kyrgyz Republic and Emissions(kt) of South Africa?
Make the answer very short. -5.27e+04. In the year 2005, what is the difference between the Emissions(kt) in Pacific island small states and Emissions(kt) in Indonesia?
Offer a terse response. -1.73e+05. In the year 2005, what is the difference between the Emissions(kt) in Pacific island small states and Emissions(kt) in Kyrgyz Republic?
Give a very brief answer. 914.39. In the year 2005, what is the difference between the Emissions(kt) in Pacific island small states and Emissions(kt) in South Africa?
Your answer should be compact. -2.56e+04. In the year 2005, what is the difference between the Emissions(kt) in Indonesia and Emissions(kt) in Kyrgyz Republic?
Ensure brevity in your answer.  1.74e+05. In the year 2005, what is the difference between the Emissions(kt) of Indonesia and Emissions(kt) of South Africa?
Provide a succinct answer. 1.47e+05. In the year 2005, what is the difference between the Emissions(kt) in Kyrgyz Republic and Emissions(kt) in South Africa?
Your response must be concise. -2.65e+04. In the year 2006, what is the difference between the Emissions(kt) of Pacific island small states and Emissions(kt) of Indonesia?
Offer a terse response. -1.50e+05. In the year 2006, what is the difference between the Emissions(kt) in Pacific island small states and Emissions(kt) in Kyrgyz Republic?
Your answer should be very brief. 1054.02. In the year 2006, what is the difference between the Emissions(kt) in Pacific island small states and Emissions(kt) in South Africa?
Offer a terse response. -5.08e+04. In the year 2006, what is the difference between the Emissions(kt) in Indonesia and Emissions(kt) in Kyrgyz Republic?
Make the answer very short. 1.51e+05. In the year 2006, what is the difference between the Emissions(kt) of Indonesia and Emissions(kt) of South Africa?
Offer a very short reply. 9.95e+04. In the year 2006, what is the difference between the Emissions(kt) in Kyrgyz Republic and Emissions(kt) in South Africa?
Your answer should be very brief. -5.19e+04. In the year 2007, what is the difference between the Emissions(kt) of Pacific island small states and Emissions(kt) of Indonesia?
Your answer should be compact. -1.64e+05. In the year 2007, what is the difference between the Emissions(kt) in Pacific island small states and Emissions(kt) in Kyrgyz Republic?
Your answer should be compact. -112.74. In the year 2007, what is the difference between the Emissions(kt) in Pacific island small states and Emissions(kt) in South Africa?
Your response must be concise. -5.72e+04. In the year 2007, what is the difference between the Emissions(kt) of Indonesia and Emissions(kt) of Kyrgyz Republic?
Your answer should be very brief. 1.64e+05. In the year 2007, what is the difference between the Emissions(kt) of Indonesia and Emissions(kt) of South Africa?
Provide a succinct answer. 1.07e+05. In the year 2007, what is the difference between the Emissions(kt) in Kyrgyz Republic and Emissions(kt) in South Africa?
Provide a short and direct response. -5.70e+04. What is the ratio of the Emissions(kt) of Pacific island small states in 2000 to that in 2001?
Ensure brevity in your answer.  0.82. What is the ratio of the Emissions(kt) in Indonesia in 2000 to that in 2001?
Make the answer very short. 1.03. What is the ratio of the Emissions(kt) in Kyrgyz Republic in 2000 to that in 2001?
Give a very brief answer. 1.11. What is the ratio of the Emissions(kt) in South Africa in 2000 to that in 2001?
Provide a short and direct response. 1.29. What is the ratio of the Emissions(kt) of Pacific island small states in 2000 to that in 2002?
Your answer should be very brief. 0.95. What is the ratio of the Emissions(kt) in Indonesia in 2000 to that in 2002?
Your answer should be compact. 0.99. What is the ratio of the Emissions(kt) in Kyrgyz Republic in 2000 to that in 2002?
Your response must be concise. 1.2. What is the ratio of the Emissions(kt) of South Africa in 2000 to that in 2002?
Provide a short and direct response. 1.48. What is the ratio of the Emissions(kt) in Pacific island small states in 2000 to that in 2003?
Make the answer very short. 0.92. What is the ratio of the Emissions(kt) in Indonesia in 2000 to that in 2003?
Provide a succinct answer. 0.95. What is the ratio of the Emissions(kt) in Kyrgyz Republic in 2000 to that in 2003?
Give a very brief answer. 0.97. What is the ratio of the Emissions(kt) of South Africa in 2000 to that in 2003?
Give a very brief answer. 0.84. What is the ratio of the Emissions(kt) in Pacific island small states in 2000 to that in 2004?
Ensure brevity in your answer.  0.79. What is the ratio of the Emissions(kt) in Indonesia in 2000 to that in 2004?
Your response must be concise. 0.89. What is the ratio of the Emissions(kt) in Kyrgyz Republic in 2000 to that in 2004?
Provide a short and direct response. 0.78. What is the ratio of the Emissions(kt) in South Africa in 2000 to that in 2004?
Make the answer very short. 0.61. What is the ratio of the Emissions(kt) of Pacific island small states in 2000 to that in 2005?
Your answer should be very brief. 0.71. What is the ratio of the Emissions(kt) of Indonesia in 2000 to that in 2005?
Your response must be concise. 0.89. What is the ratio of the Emissions(kt) of Kyrgyz Republic in 2000 to that in 2005?
Make the answer very short. 0.88. What is the ratio of the Emissions(kt) of South Africa in 2000 to that in 2005?
Make the answer very short. 1.2. What is the ratio of the Emissions(kt) of Pacific island small states in 2000 to that in 2006?
Offer a terse response. 0.7. What is the ratio of the Emissions(kt) of Indonesia in 2000 to that in 2006?
Your response must be concise. 1.02. What is the ratio of the Emissions(kt) in Kyrgyz Republic in 2000 to that in 2006?
Ensure brevity in your answer.  0.95. What is the ratio of the Emissions(kt) in South Africa in 2000 to that in 2006?
Offer a terse response. 0.63. What is the ratio of the Emissions(kt) of Pacific island small states in 2000 to that in 2007?
Offer a terse response. 0.73. What is the ratio of the Emissions(kt) of Indonesia in 2000 to that in 2007?
Make the answer very short. 0.93. What is the ratio of the Emissions(kt) in Kyrgyz Republic in 2000 to that in 2007?
Your answer should be compact. 0.51. What is the ratio of the Emissions(kt) of South Africa in 2000 to that in 2007?
Offer a terse response. 0.56. What is the ratio of the Emissions(kt) in Pacific island small states in 2001 to that in 2002?
Make the answer very short. 1.17. What is the ratio of the Emissions(kt) of Indonesia in 2001 to that in 2002?
Make the answer very short. 0.96. What is the ratio of the Emissions(kt) of Kyrgyz Republic in 2001 to that in 2002?
Give a very brief answer. 1.08. What is the ratio of the Emissions(kt) in South Africa in 2001 to that in 2002?
Your response must be concise. 1.15. What is the ratio of the Emissions(kt) in Pacific island small states in 2001 to that in 2003?
Your answer should be compact. 1.13. What is the ratio of the Emissions(kt) in Indonesia in 2001 to that in 2003?
Your answer should be compact. 0.92. What is the ratio of the Emissions(kt) of Kyrgyz Republic in 2001 to that in 2003?
Give a very brief answer. 0.87. What is the ratio of the Emissions(kt) of South Africa in 2001 to that in 2003?
Your response must be concise. 0.65. What is the ratio of the Emissions(kt) in Pacific island small states in 2001 to that in 2004?
Provide a succinct answer. 0.97. What is the ratio of the Emissions(kt) of Indonesia in 2001 to that in 2004?
Offer a terse response. 0.86. What is the ratio of the Emissions(kt) of Kyrgyz Republic in 2001 to that in 2004?
Your answer should be compact. 0.7. What is the ratio of the Emissions(kt) of South Africa in 2001 to that in 2004?
Offer a terse response. 0.48. What is the ratio of the Emissions(kt) of Pacific island small states in 2001 to that in 2005?
Ensure brevity in your answer.  0.87. What is the ratio of the Emissions(kt) in Indonesia in 2001 to that in 2005?
Your response must be concise. 0.86. What is the ratio of the Emissions(kt) in Kyrgyz Republic in 2001 to that in 2005?
Give a very brief answer. 0.79. What is the ratio of the Emissions(kt) of South Africa in 2001 to that in 2005?
Provide a short and direct response. 0.93. What is the ratio of the Emissions(kt) in Pacific island small states in 2001 to that in 2006?
Ensure brevity in your answer.  0.86. What is the ratio of the Emissions(kt) of Indonesia in 2001 to that in 2006?
Ensure brevity in your answer.  0.98. What is the ratio of the Emissions(kt) in Kyrgyz Republic in 2001 to that in 2006?
Provide a short and direct response. 0.85. What is the ratio of the Emissions(kt) in South Africa in 2001 to that in 2006?
Your answer should be compact. 0.49. What is the ratio of the Emissions(kt) in Pacific island small states in 2001 to that in 2007?
Ensure brevity in your answer.  0.89. What is the ratio of the Emissions(kt) in Indonesia in 2001 to that in 2007?
Keep it short and to the point. 0.9. What is the ratio of the Emissions(kt) of Kyrgyz Republic in 2001 to that in 2007?
Make the answer very short. 0.46. What is the ratio of the Emissions(kt) of South Africa in 2001 to that in 2007?
Provide a succinct answer. 0.44. What is the ratio of the Emissions(kt) in Pacific island small states in 2002 to that in 2003?
Your answer should be compact. 0.97. What is the ratio of the Emissions(kt) in Indonesia in 2002 to that in 2003?
Ensure brevity in your answer.  0.97. What is the ratio of the Emissions(kt) in Kyrgyz Republic in 2002 to that in 2003?
Make the answer very short. 0.81. What is the ratio of the Emissions(kt) of South Africa in 2002 to that in 2003?
Provide a succinct answer. 0.56. What is the ratio of the Emissions(kt) in Pacific island small states in 2002 to that in 2004?
Your response must be concise. 0.83. What is the ratio of the Emissions(kt) in Indonesia in 2002 to that in 2004?
Provide a succinct answer. 0.9. What is the ratio of the Emissions(kt) in Kyrgyz Republic in 2002 to that in 2004?
Your response must be concise. 0.65. What is the ratio of the Emissions(kt) in South Africa in 2002 to that in 2004?
Provide a succinct answer. 0.41. What is the ratio of the Emissions(kt) of Pacific island small states in 2002 to that in 2005?
Ensure brevity in your answer.  0.75. What is the ratio of the Emissions(kt) of Indonesia in 2002 to that in 2005?
Your answer should be compact. 0.9. What is the ratio of the Emissions(kt) of Kyrgyz Republic in 2002 to that in 2005?
Keep it short and to the point. 0.73. What is the ratio of the Emissions(kt) of South Africa in 2002 to that in 2005?
Make the answer very short. 0.81. What is the ratio of the Emissions(kt) of Pacific island small states in 2002 to that in 2006?
Ensure brevity in your answer.  0.73. What is the ratio of the Emissions(kt) of Indonesia in 2002 to that in 2006?
Give a very brief answer. 1.03. What is the ratio of the Emissions(kt) of Kyrgyz Republic in 2002 to that in 2006?
Keep it short and to the point. 0.79. What is the ratio of the Emissions(kt) in South Africa in 2002 to that in 2006?
Provide a succinct answer. 0.42. What is the ratio of the Emissions(kt) of Pacific island small states in 2002 to that in 2007?
Your answer should be compact. 0.77. What is the ratio of the Emissions(kt) in Indonesia in 2002 to that in 2007?
Give a very brief answer. 0.94. What is the ratio of the Emissions(kt) of Kyrgyz Republic in 2002 to that in 2007?
Give a very brief answer. 0.43. What is the ratio of the Emissions(kt) in South Africa in 2002 to that in 2007?
Offer a very short reply. 0.38. What is the ratio of the Emissions(kt) in Pacific island small states in 2003 to that in 2004?
Offer a very short reply. 0.85. What is the ratio of the Emissions(kt) in Indonesia in 2003 to that in 2004?
Offer a very short reply. 0.93. What is the ratio of the Emissions(kt) in Kyrgyz Republic in 2003 to that in 2004?
Make the answer very short. 0.81. What is the ratio of the Emissions(kt) of South Africa in 2003 to that in 2004?
Provide a short and direct response. 0.73. What is the ratio of the Emissions(kt) in Pacific island small states in 2003 to that in 2005?
Give a very brief answer. 0.77. What is the ratio of the Emissions(kt) of Indonesia in 2003 to that in 2005?
Give a very brief answer. 0.93. What is the ratio of the Emissions(kt) in South Africa in 2003 to that in 2005?
Make the answer very short. 1.43. What is the ratio of the Emissions(kt) in Pacific island small states in 2003 to that in 2006?
Your answer should be very brief. 0.76. What is the ratio of the Emissions(kt) in Indonesia in 2003 to that in 2006?
Make the answer very short. 1.07. What is the ratio of the Emissions(kt) in Kyrgyz Republic in 2003 to that in 2006?
Provide a short and direct response. 0.98. What is the ratio of the Emissions(kt) in South Africa in 2003 to that in 2006?
Give a very brief answer. 0.75. What is the ratio of the Emissions(kt) in Pacific island small states in 2003 to that in 2007?
Your answer should be compact. 0.79. What is the ratio of the Emissions(kt) of Indonesia in 2003 to that in 2007?
Offer a terse response. 0.98. What is the ratio of the Emissions(kt) of Kyrgyz Republic in 2003 to that in 2007?
Your answer should be compact. 0.53. What is the ratio of the Emissions(kt) of South Africa in 2003 to that in 2007?
Your answer should be compact. 0.67. What is the ratio of the Emissions(kt) in Pacific island small states in 2004 to that in 2005?
Give a very brief answer. 0.9. What is the ratio of the Emissions(kt) of Kyrgyz Republic in 2004 to that in 2005?
Ensure brevity in your answer.  1.13. What is the ratio of the Emissions(kt) in South Africa in 2004 to that in 2005?
Provide a short and direct response. 1.95. What is the ratio of the Emissions(kt) in Pacific island small states in 2004 to that in 2006?
Make the answer very short. 0.89. What is the ratio of the Emissions(kt) in Indonesia in 2004 to that in 2006?
Your answer should be very brief. 1.14. What is the ratio of the Emissions(kt) in Kyrgyz Republic in 2004 to that in 2006?
Keep it short and to the point. 1.21. What is the ratio of the Emissions(kt) of South Africa in 2004 to that in 2006?
Provide a short and direct response. 1.02. What is the ratio of the Emissions(kt) of Pacific island small states in 2004 to that in 2007?
Give a very brief answer. 0.92. What is the ratio of the Emissions(kt) in Indonesia in 2004 to that in 2007?
Your response must be concise. 1.05. What is the ratio of the Emissions(kt) in Kyrgyz Republic in 2004 to that in 2007?
Give a very brief answer. 0.66. What is the ratio of the Emissions(kt) of South Africa in 2004 to that in 2007?
Ensure brevity in your answer.  0.91. What is the ratio of the Emissions(kt) in Pacific island small states in 2005 to that in 2006?
Make the answer very short. 0.98. What is the ratio of the Emissions(kt) in Indonesia in 2005 to that in 2006?
Your response must be concise. 1.15. What is the ratio of the Emissions(kt) in Kyrgyz Republic in 2005 to that in 2006?
Provide a succinct answer. 1.08. What is the ratio of the Emissions(kt) in South Africa in 2005 to that in 2006?
Your response must be concise. 0.52. What is the ratio of the Emissions(kt) in Pacific island small states in 2005 to that in 2007?
Your response must be concise. 1.02. What is the ratio of the Emissions(kt) of Indonesia in 2005 to that in 2007?
Provide a succinct answer. 1.05. What is the ratio of the Emissions(kt) of Kyrgyz Republic in 2005 to that in 2007?
Your response must be concise. 0.58. What is the ratio of the Emissions(kt) in South Africa in 2005 to that in 2007?
Your answer should be compact. 0.47. What is the ratio of the Emissions(kt) in Pacific island small states in 2006 to that in 2007?
Give a very brief answer. 1.04. What is the ratio of the Emissions(kt) in Indonesia in 2006 to that in 2007?
Offer a terse response. 0.92. What is the ratio of the Emissions(kt) of Kyrgyz Republic in 2006 to that in 2007?
Provide a short and direct response. 0.54. What is the ratio of the Emissions(kt) in South Africa in 2006 to that in 2007?
Make the answer very short. 0.89. What is the difference between the highest and the second highest Emissions(kt) of Pacific island small states?
Ensure brevity in your answer.  40.62. What is the difference between the highest and the second highest Emissions(kt) of Indonesia?
Give a very brief answer. 861.75. What is the difference between the highest and the second highest Emissions(kt) in Kyrgyz Republic?
Offer a terse response. 803.07. What is the difference between the highest and the second highest Emissions(kt) in South Africa?
Offer a terse response. 5104.46. What is the difference between the highest and the lowest Emissions(kt) in Pacific island small states?
Offer a very short reply. 697.94. What is the difference between the highest and the lowest Emissions(kt) of Indonesia?
Keep it short and to the point. 2.49e+04. What is the difference between the highest and the lowest Emissions(kt) of Kyrgyz Republic?
Your answer should be compact. 1342.12. What is the difference between the highest and the lowest Emissions(kt) of South Africa?
Offer a very short reply. 3.69e+04. 